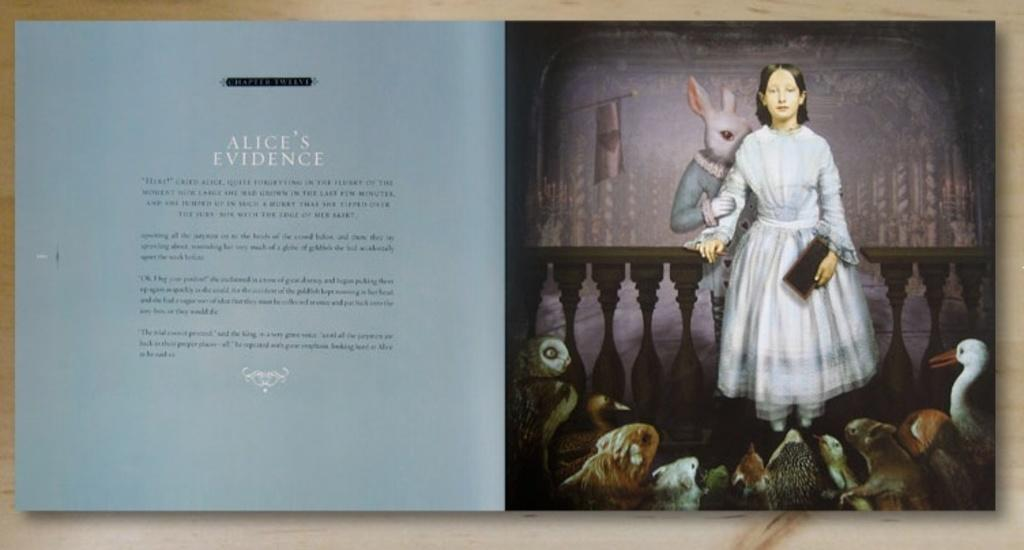What is the person in the image holding? The person is holding a book. What is the animal in the image holding? The animal is holding a fencing. What can be seen in the background of the image? There is a flag and pillars in the image. Are there any animals in the front of the image? Yes, there are animals present in the front of the image. What type of seed can be seen growing on the person's head in the image? There is no seed growing on the person's head in the image. 